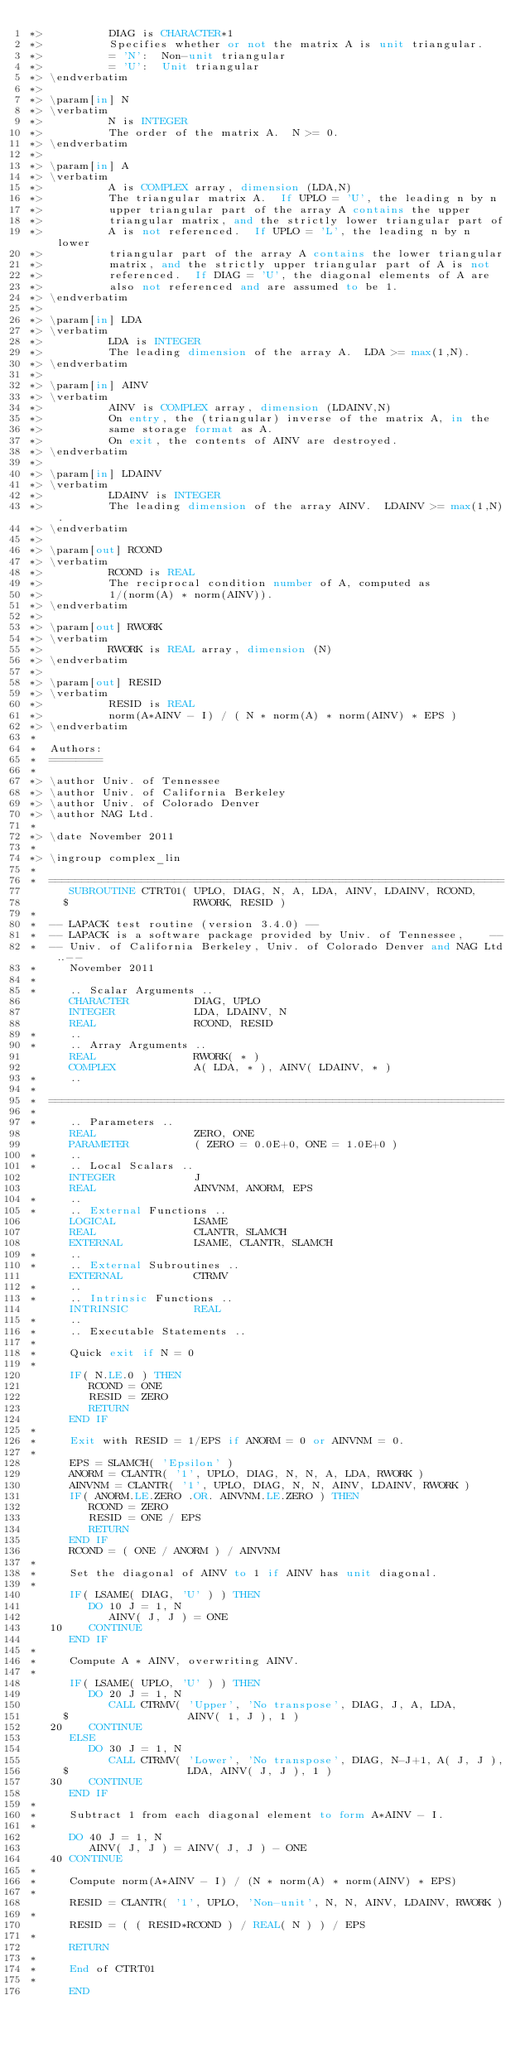Convert code to text. <code><loc_0><loc_0><loc_500><loc_500><_FORTRAN_>*>          DIAG is CHARACTER*1
*>          Specifies whether or not the matrix A is unit triangular.
*>          = 'N':  Non-unit triangular
*>          = 'U':  Unit triangular
*> \endverbatim
*>
*> \param[in] N
*> \verbatim
*>          N is INTEGER
*>          The order of the matrix A.  N >= 0.
*> \endverbatim
*>
*> \param[in] A
*> \verbatim
*>          A is COMPLEX array, dimension (LDA,N)
*>          The triangular matrix A.  If UPLO = 'U', the leading n by n
*>          upper triangular part of the array A contains the upper
*>          triangular matrix, and the strictly lower triangular part of
*>          A is not referenced.  If UPLO = 'L', the leading n by n lower
*>          triangular part of the array A contains the lower triangular
*>          matrix, and the strictly upper triangular part of A is not
*>          referenced.  If DIAG = 'U', the diagonal elements of A are
*>          also not referenced and are assumed to be 1.
*> \endverbatim
*>
*> \param[in] LDA
*> \verbatim
*>          LDA is INTEGER
*>          The leading dimension of the array A.  LDA >= max(1,N).
*> \endverbatim
*>
*> \param[in] AINV
*> \verbatim
*>          AINV is COMPLEX array, dimension (LDAINV,N)
*>          On entry, the (triangular) inverse of the matrix A, in the
*>          same storage format as A.
*>          On exit, the contents of AINV are destroyed.
*> \endverbatim
*>
*> \param[in] LDAINV
*> \verbatim
*>          LDAINV is INTEGER
*>          The leading dimension of the array AINV.  LDAINV >= max(1,N).
*> \endverbatim
*>
*> \param[out] RCOND
*> \verbatim
*>          RCOND is REAL
*>          The reciprocal condition number of A, computed as
*>          1/(norm(A) * norm(AINV)).
*> \endverbatim
*>
*> \param[out] RWORK
*> \verbatim
*>          RWORK is REAL array, dimension (N)
*> \endverbatim
*>
*> \param[out] RESID
*> \verbatim
*>          RESID is REAL
*>          norm(A*AINV - I) / ( N * norm(A) * norm(AINV) * EPS )
*> \endverbatim
*
*  Authors:
*  ========
*
*> \author Univ. of Tennessee
*> \author Univ. of California Berkeley
*> \author Univ. of Colorado Denver
*> \author NAG Ltd.
*
*> \date November 2011
*
*> \ingroup complex_lin
*
*  =====================================================================
      SUBROUTINE CTRT01( UPLO, DIAG, N, A, LDA, AINV, LDAINV, RCOND,
     $                   RWORK, RESID )
*
*  -- LAPACK test routine (version 3.4.0) --
*  -- LAPACK is a software package provided by Univ. of Tennessee,    --
*  -- Univ. of California Berkeley, Univ. of Colorado Denver and NAG Ltd..--
*     November 2011
*
*     .. Scalar Arguments ..
      CHARACTER          DIAG, UPLO
      INTEGER            LDA, LDAINV, N
      REAL               RCOND, RESID
*     ..
*     .. Array Arguments ..
      REAL               RWORK( * )
      COMPLEX            A( LDA, * ), AINV( LDAINV, * )
*     ..
*
*  =====================================================================
*
*     .. Parameters ..
      REAL               ZERO, ONE
      PARAMETER          ( ZERO = 0.0E+0, ONE = 1.0E+0 )
*     ..
*     .. Local Scalars ..
      INTEGER            J
      REAL               AINVNM, ANORM, EPS
*     ..
*     .. External Functions ..
      LOGICAL            LSAME
      REAL               CLANTR, SLAMCH
      EXTERNAL           LSAME, CLANTR, SLAMCH
*     ..
*     .. External Subroutines ..
      EXTERNAL           CTRMV
*     ..
*     .. Intrinsic Functions ..
      INTRINSIC          REAL
*     ..
*     .. Executable Statements ..
*
*     Quick exit if N = 0
*
      IF( N.LE.0 ) THEN
         RCOND = ONE
         RESID = ZERO
         RETURN
      END IF
*
*     Exit with RESID = 1/EPS if ANORM = 0 or AINVNM = 0.
*
      EPS = SLAMCH( 'Epsilon' )
      ANORM = CLANTR( '1', UPLO, DIAG, N, N, A, LDA, RWORK )
      AINVNM = CLANTR( '1', UPLO, DIAG, N, N, AINV, LDAINV, RWORK )
      IF( ANORM.LE.ZERO .OR. AINVNM.LE.ZERO ) THEN
         RCOND = ZERO
         RESID = ONE / EPS
         RETURN
      END IF
      RCOND = ( ONE / ANORM ) / AINVNM
*
*     Set the diagonal of AINV to 1 if AINV has unit diagonal.
*
      IF( LSAME( DIAG, 'U' ) ) THEN
         DO 10 J = 1, N
            AINV( J, J ) = ONE
   10    CONTINUE
      END IF
*
*     Compute A * AINV, overwriting AINV.
*
      IF( LSAME( UPLO, 'U' ) ) THEN
         DO 20 J = 1, N
            CALL CTRMV( 'Upper', 'No transpose', DIAG, J, A, LDA,
     $                  AINV( 1, J ), 1 )
   20    CONTINUE
      ELSE
         DO 30 J = 1, N
            CALL CTRMV( 'Lower', 'No transpose', DIAG, N-J+1, A( J, J ),
     $                  LDA, AINV( J, J ), 1 )
   30    CONTINUE
      END IF
*
*     Subtract 1 from each diagonal element to form A*AINV - I.
*
      DO 40 J = 1, N
         AINV( J, J ) = AINV( J, J ) - ONE
   40 CONTINUE
*
*     Compute norm(A*AINV - I) / (N * norm(A) * norm(AINV) * EPS)
*
      RESID = CLANTR( '1', UPLO, 'Non-unit', N, N, AINV, LDAINV, RWORK )
*
      RESID = ( ( RESID*RCOND ) / REAL( N ) ) / EPS
*
      RETURN
*
*     End of CTRT01
*
      END
</code> 